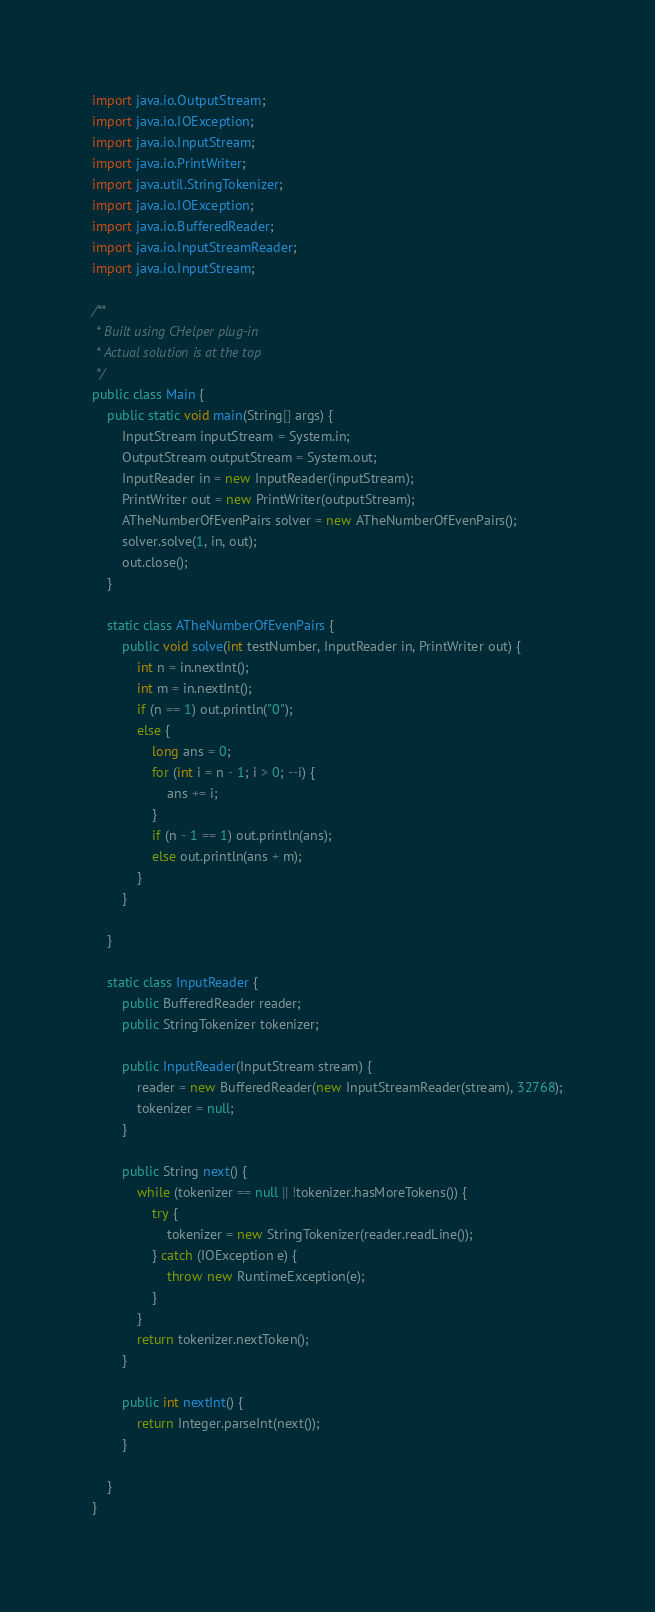Convert code to text. <code><loc_0><loc_0><loc_500><loc_500><_Java_>import java.io.OutputStream;
import java.io.IOException;
import java.io.InputStream;
import java.io.PrintWriter;
import java.util.StringTokenizer;
import java.io.IOException;
import java.io.BufferedReader;
import java.io.InputStreamReader;
import java.io.InputStream;

/**
 * Built using CHelper plug-in
 * Actual solution is at the top
 */
public class Main {
    public static void main(String[] args) {
        InputStream inputStream = System.in;
        OutputStream outputStream = System.out;
        InputReader in = new InputReader(inputStream);
        PrintWriter out = new PrintWriter(outputStream);
        ATheNumberOfEvenPairs solver = new ATheNumberOfEvenPairs();
        solver.solve(1, in, out);
        out.close();
    }

    static class ATheNumberOfEvenPairs {
        public void solve(int testNumber, InputReader in, PrintWriter out) {
            int n = in.nextInt();
            int m = in.nextInt();
            if (n == 1) out.println("0");
            else {
                long ans = 0;
                for (int i = n - 1; i > 0; --i) {
                    ans += i;
                }
                if (n - 1 == 1) out.println(ans);
                else out.println(ans + m);
            }
        }

    }

    static class InputReader {
        public BufferedReader reader;
        public StringTokenizer tokenizer;

        public InputReader(InputStream stream) {
            reader = new BufferedReader(new InputStreamReader(stream), 32768);
            tokenizer = null;
        }

        public String next() {
            while (tokenizer == null || !tokenizer.hasMoreTokens()) {
                try {
                    tokenizer = new StringTokenizer(reader.readLine());
                } catch (IOException e) {
                    throw new RuntimeException(e);
                }
            }
            return tokenizer.nextToken();
        }

        public int nextInt() {
            return Integer.parseInt(next());
        }

    }
}

</code> 